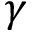<formula> <loc_0><loc_0><loc_500><loc_500>\gamma</formula> 